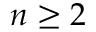<formula> <loc_0><loc_0><loc_500><loc_500>n \geq 2</formula> 